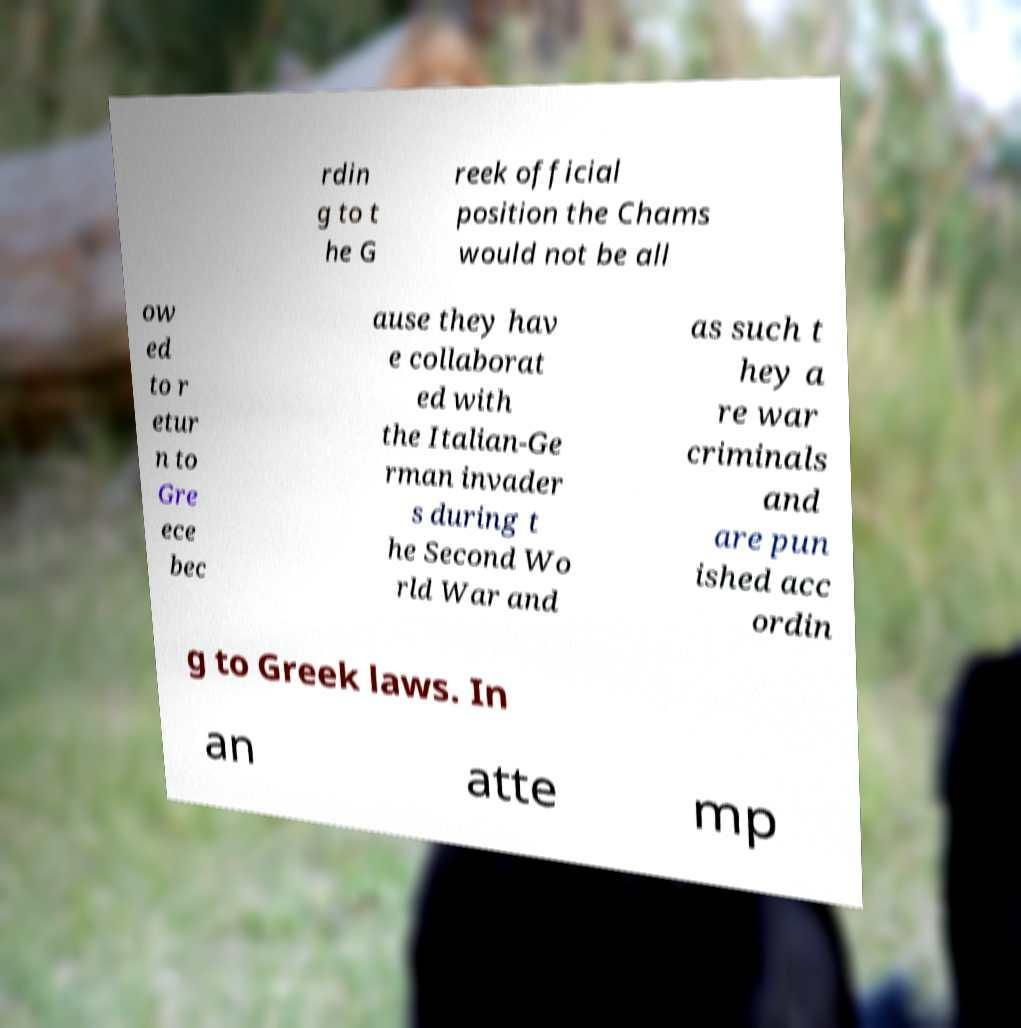What messages or text are displayed in this image? I need them in a readable, typed format. rdin g to t he G reek official position the Chams would not be all ow ed to r etur n to Gre ece bec ause they hav e collaborat ed with the Italian-Ge rman invader s during t he Second Wo rld War and as such t hey a re war criminals and are pun ished acc ordin g to Greek laws. In an atte mp 